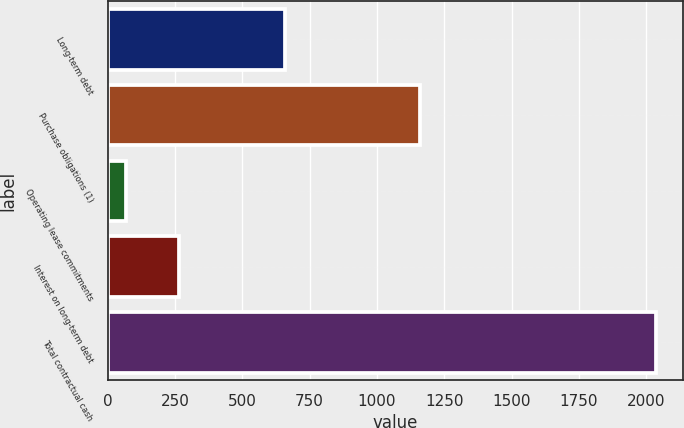<chart> <loc_0><loc_0><loc_500><loc_500><bar_chart><fcel>Long-term debt<fcel>Purchase obligations (1)<fcel>Operating lease commitments<fcel>Interest on long-term debt<fcel>Total contractual cash<nl><fcel>657<fcel>1160<fcel>68<fcel>264.7<fcel>2035<nl></chart> 